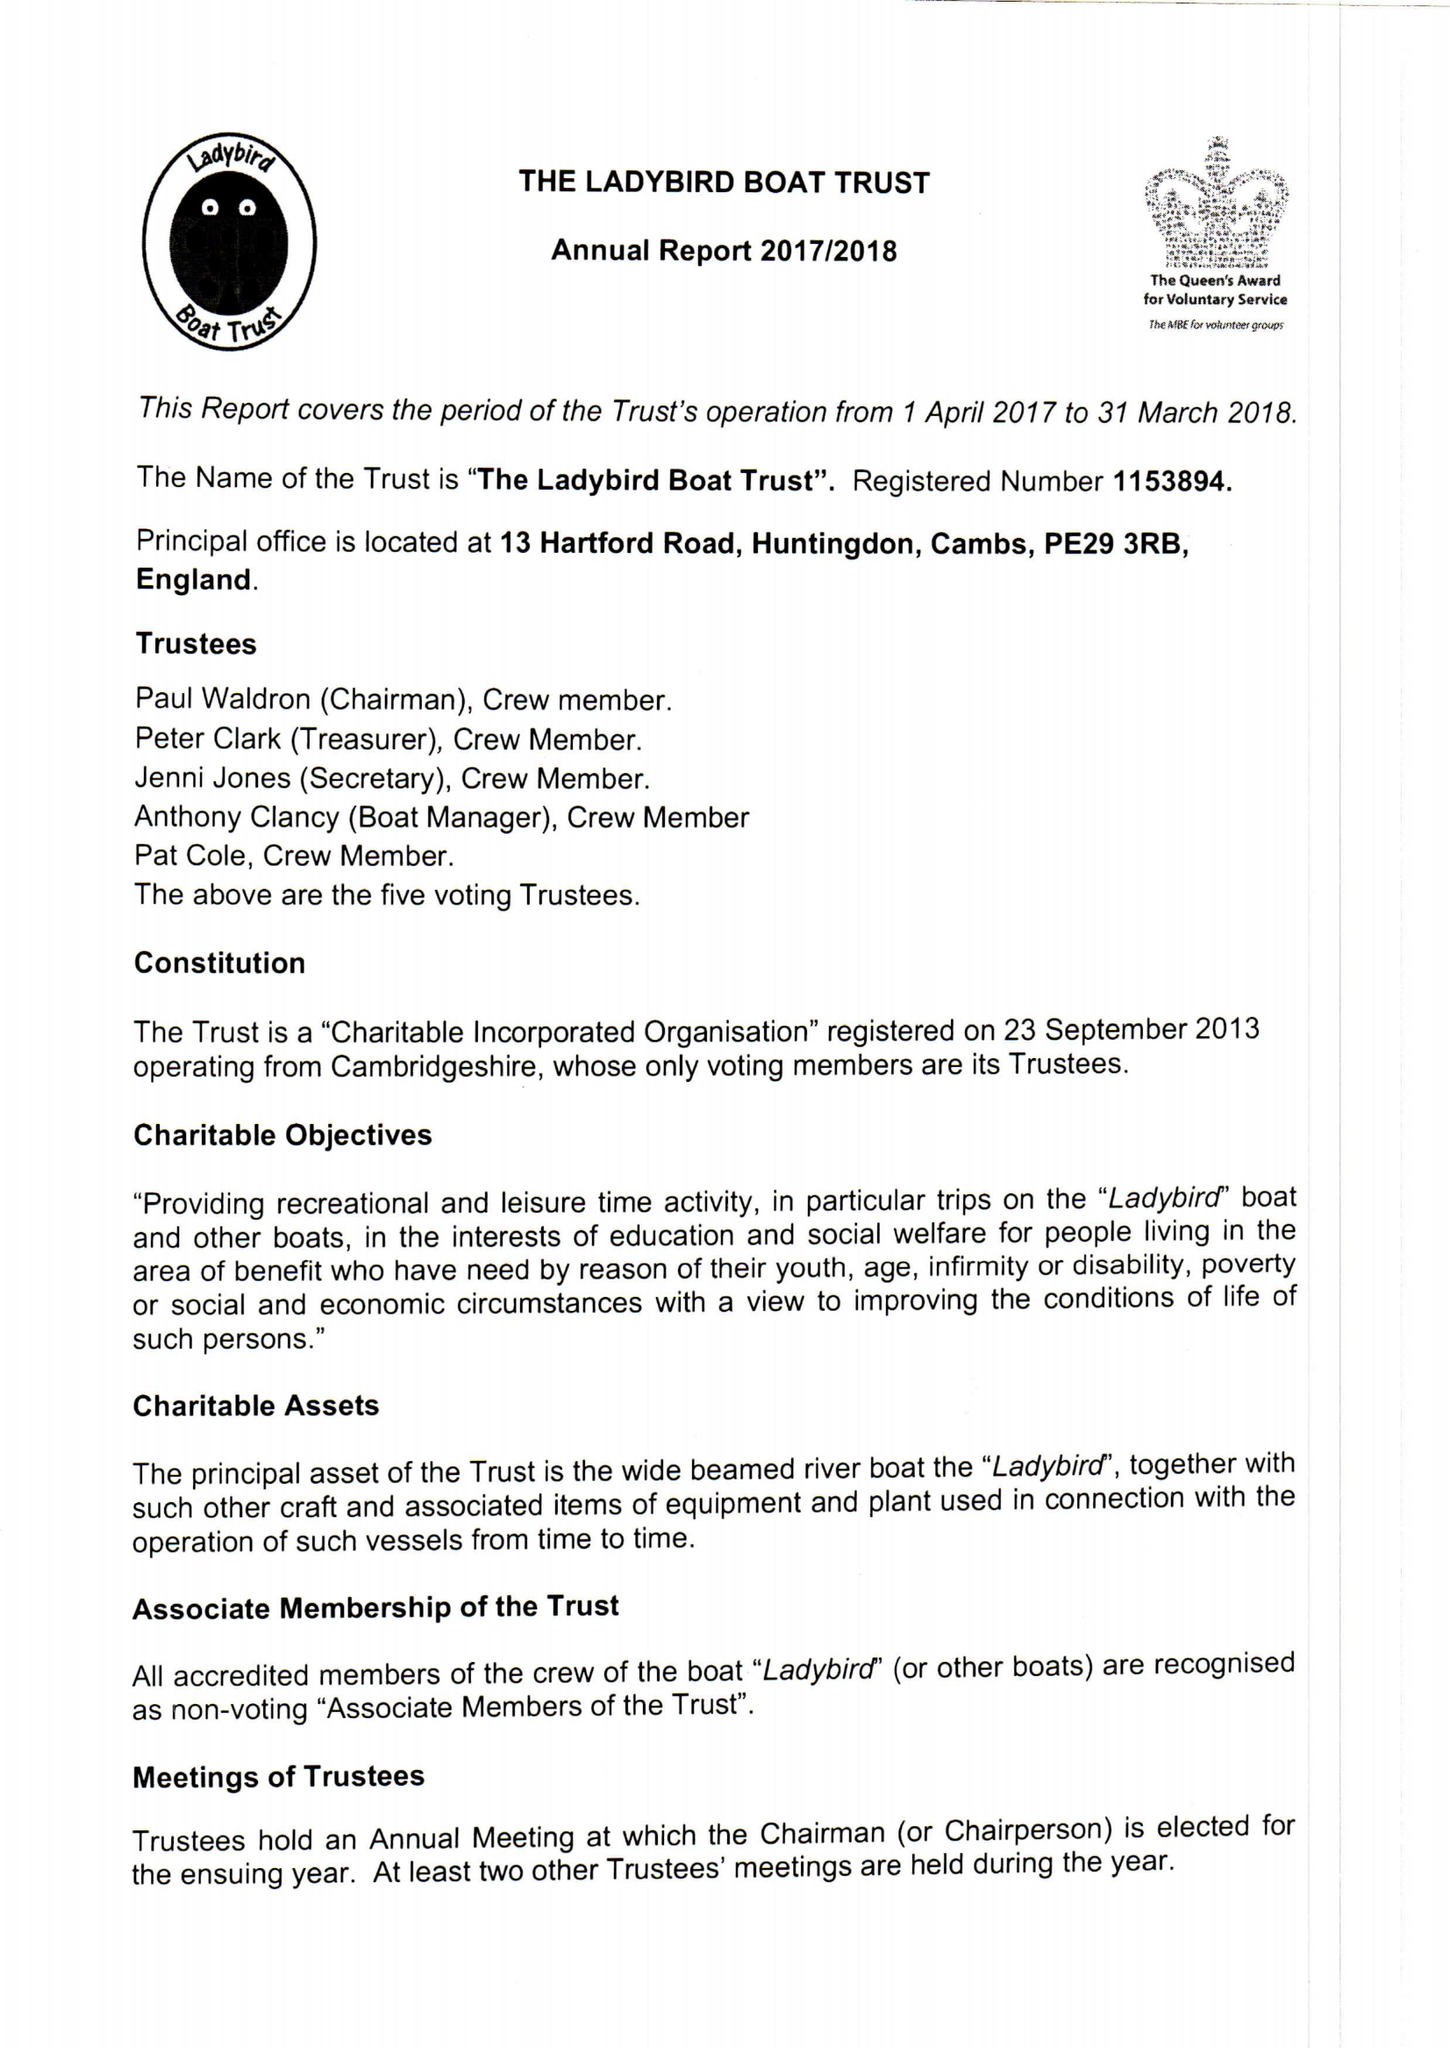What is the value for the spending_annually_in_british_pounds?
Answer the question using a single word or phrase. 12108.00 